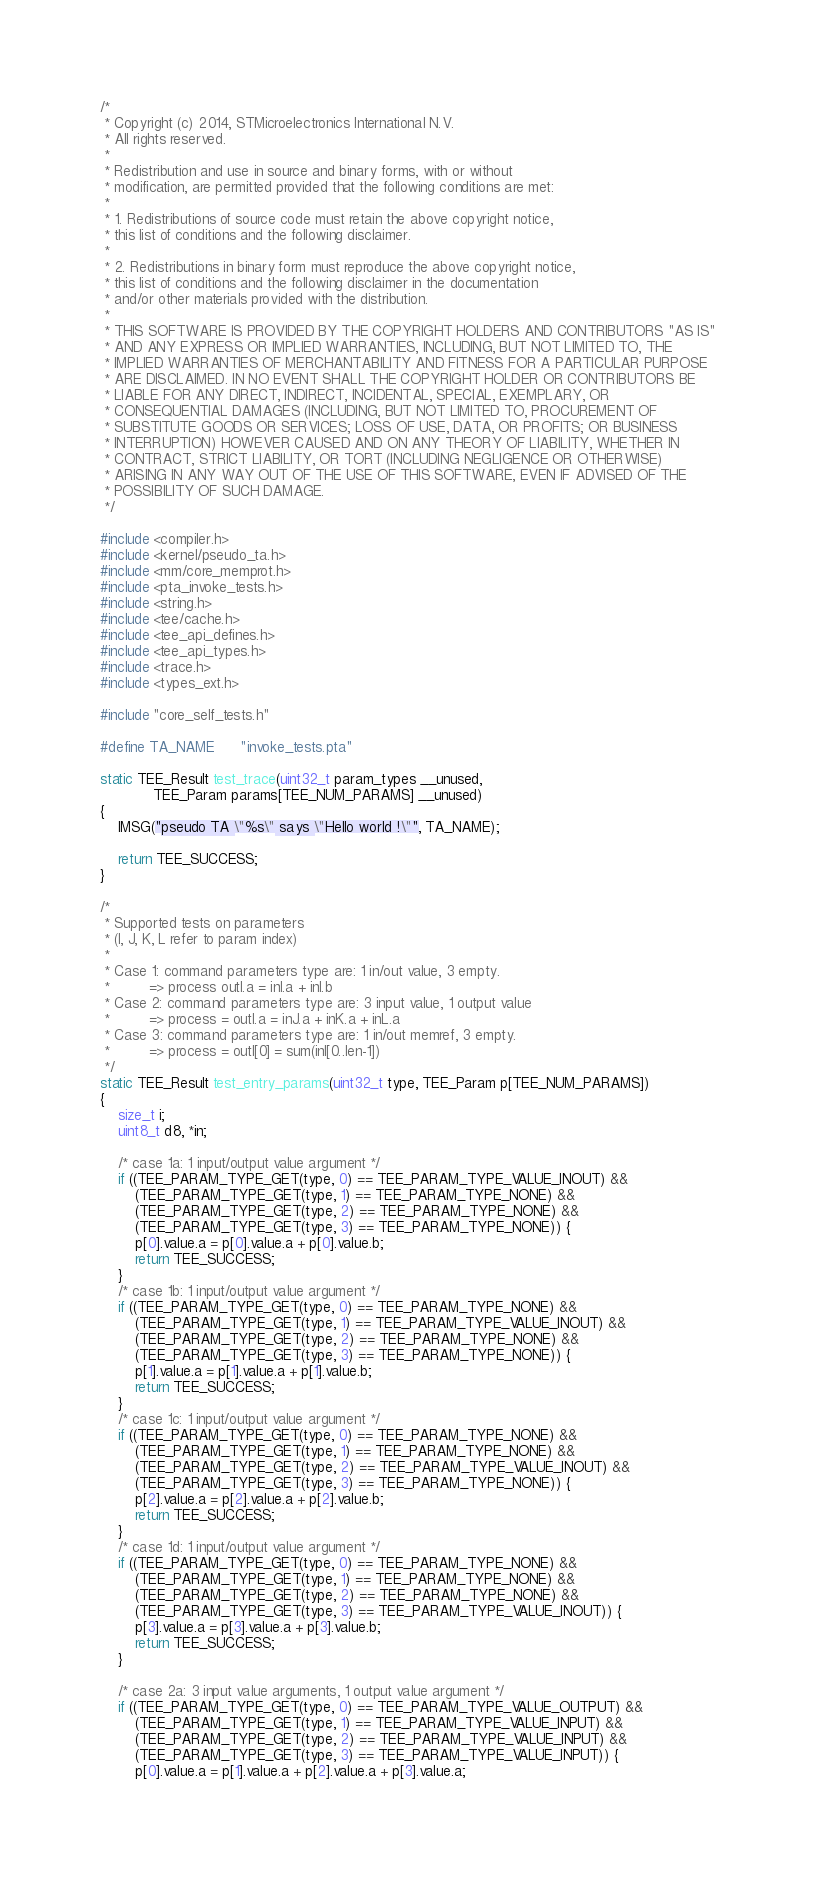<code> <loc_0><loc_0><loc_500><loc_500><_C_>/*
 * Copyright (c) 2014, STMicroelectronics International N.V.
 * All rights reserved.
 *
 * Redistribution and use in source and binary forms, with or without
 * modification, are permitted provided that the following conditions are met:
 *
 * 1. Redistributions of source code must retain the above copyright notice,
 * this list of conditions and the following disclaimer.
 *
 * 2. Redistributions in binary form must reproduce the above copyright notice,
 * this list of conditions and the following disclaimer in the documentation
 * and/or other materials provided with the distribution.
 *
 * THIS SOFTWARE IS PROVIDED BY THE COPYRIGHT HOLDERS AND CONTRIBUTORS "AS IS"
 * AND ANY EXPRESS OR IMPLIED WARRANTIES, INCLUDING, BUT NOT LIMITED TO, THE
 * IMPLIED WARRANTIES OF MERCHANTABILITY AND FITNESS FOR A PARTICULAR PURPOSE
 * ARE DISCLAIMED. IN NO EVENT SHALL THE COPYRIGHT HOLDER OR CONTRIBUTORS BE
 * LIABLE FOR ANY DIRECT, INDIRECT, INCIDENTAL, SPECIAL, EXEMPLARY, OR
 * CONSEQUENTIAL DAMAGES (INCLUDING, BUT NOT LIMITED TO, PROCUREMENT OF
 * SUBSTITUTE GOODS OR SERVICES; LOSS OF USE, DATA, OR PROFITS; OR BUSINESS
 * INTERRUPTION) HOWEVER CAUSED AND ON ANY THEORY OF LIABILITY, WHETHER IN
 * CONTRACT, STRICT LIABILITY, OR TORT (INCLUDING NEGLIGENCE OR OTHERWISE)
 * ARISING IN ANY WAY OUT OF THE USE OF THIS SOFTWARE, EVEN IF ADVISED OF THE
 * POSSIBILITY OF SUCH DAMAGE.
 */

#include <compiler.h>
#include <kernel/pseudo_ta.h>
#include <mm/core_memprot.h>
#include <pta_invoke_tests.h>
#include <string.h>
#include <tee/cache.h>
#include <tee_api_defines.h>
#include <tee_api_types.h>
#include <trace.h>
#include <types_ext.h>

#include "core_self_tests.h"

#define TA_NAME		"invoke_tests.pta"

static TEE_Result test_trace(uint32_t param_types __unused,
			TEE_Param params[TEE_NUM_PARAMS] __unused)
{
	IMSG("pseudo TA \"%s\" says \"Hello world !\"", TA_NAME);

	return TEE_SUCCESS;
}

/*
 * Supported tests on parameters
 * (I, J, K, L refer to param index)
 *
 * Case 1: command parameters type are: 1 in/out value, 3 empty.
 *         => process outI.a = inI.a + inI.b
 * Case 2: command parameters type are: 3 input value, 1 output value
 *         => process = outI.a = inJ.a + inK.a + inL.a
 * Case 3: command parameters type are: 1 in/out memref, 3 empty.
 *         => process = outI[0] = sum(inI[0..len-1])
 */
static TEE_Result test_entry_params(uint32_t type, TEE_Param p[TEE_NUM_PARAMS])
{
	size_t i;
	uint8_t d8, *in;

	/* case 1a: 1 input/output value argument */
	if ((TEE_PARAM_TYPE_GET(type, 0) == TEE_PARAM_TYPE_VALUE_INOUT) &&
		(TEE_PARAM_TYPE_GET(type, 1) == TEE_PARAM_TYPE_NONE) &&
		(TEE_PARAM_TYPE_GET(type, 2) == TEE_PARAM_TYPE_NONE) &&
		(TEE_PARAM_TYPE_GET(type, 3) == TEE_PARAM_TYPE_NONE)) {
		p[0].value.a = p[0].value.a + p[0].value.b;
		return TEE_SUCCESS;
	}
	/* case 1b: 1 input/output value argument */
	if ((TEE_PARAM_TYPE_GET(type, 0) == TEE_PARAM_TYPE_NONE) &&
		(TEE_PARAM_TYPE_GET(type, 1) == TEE_PARAM_TYPE_VALUE_INOUT) &&
		(TEE_PARAM_TYPE_GET(type, 2) == TEE_PARAM_TYPE_NONE) &&
		(TEE_PARAM_TYPE_GET(type, 3) == TEE_PARAM_TYPE_NONE)) {
		p[1].value.a = p[1].value.a + p[1].value.b;
		return TEE_SUCCESS;
	}
	/* case 1c: 1 input/output value argument */
	if ((TEE_PARAM_TYPE_GET(type, 0) == TEE_PARAM_TYPE_NONE) &&
		(TEE_PARAM_TYPE_GET(type, 1) == TEE_PARAM_TYPE_NONE) &&
		(TEE_PARAM_TYPE_GET(type, 2) == TEE_PARAM_TYPE_VALUE_INOUT) &&
		(TEE_PARAM_TYPE_GET(type, 3) == TEE_PARAM_TYPE_NONE)) {
		p[2].value.a = p[2].value.a + p[2].value.b;
		return TEE_SUCCESS;
	}
	/* case 1d: 1 input/output value argument */
	if ((TEE_PARAM_TYPE_GET(type, 0) == TEE_PARAM_TYPE_NONE) &&
		(TEE_PARAM_TYPE_GET(type, 1) == TEE_PARAM_TYPE_NONE) &&
		(TEE_PARAM_TYPE_GET(type, 2) == TEE_PARAM_TYPE_NONE) &&
		(TEE_PARAM_TYPE_GET(type, 3) == TEE_PARAM_TYPE_VALUE_INOUT)) {
		p[3].value.a = p[3].value.a + p[3].value.b;
		return TEE_SUCCESS;
	}

	/* case 2a: 3 input value arguments, 1 output value argument */
	if ((TEE_PARAM_TYPE_GET(type, 0) == TEE_PARAM_TYPE_VALUE_OUTPUT) &&
		(TEE_PARAM_TYPE_GET(type, 1) == TEE_PARAM_TYPE_VALUE_INPUT) &&
		(TEE_PARAM_TYPE_GET(type, 2) == TEE_PARAM_TYPE_VALUE_INPUT) &&
		(TEE_PARAM_TYPE_GET(type, 3) == TEE_PARAM_TYPE_VALUE_INPUT)) {
		p[0].value.a = p[1].value.a + p[2].value.a + p[3].value.a;</code> 